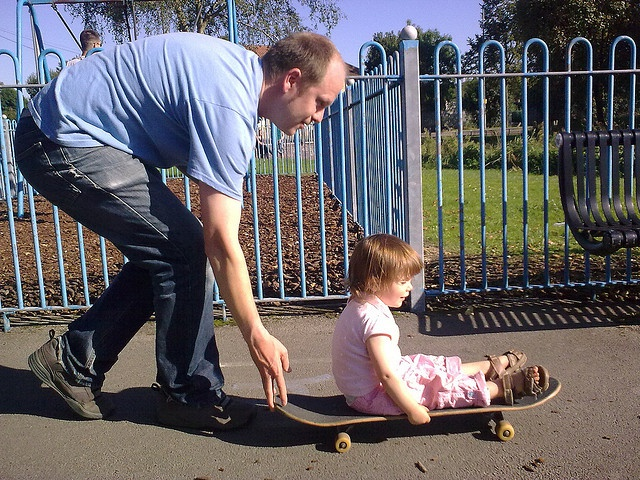Describe the objects in this image and their specific colors. I can see people in lightblue, black, lavender, gray, and darkgray tones, people in lightblue, white, brown, and maroon tones, bench in lightblue, black, gray, and olive tones, skateboard in lightblue, black, gray, and tan tones, and people in lightblue, black, gray, and darkgray tones in this image. 